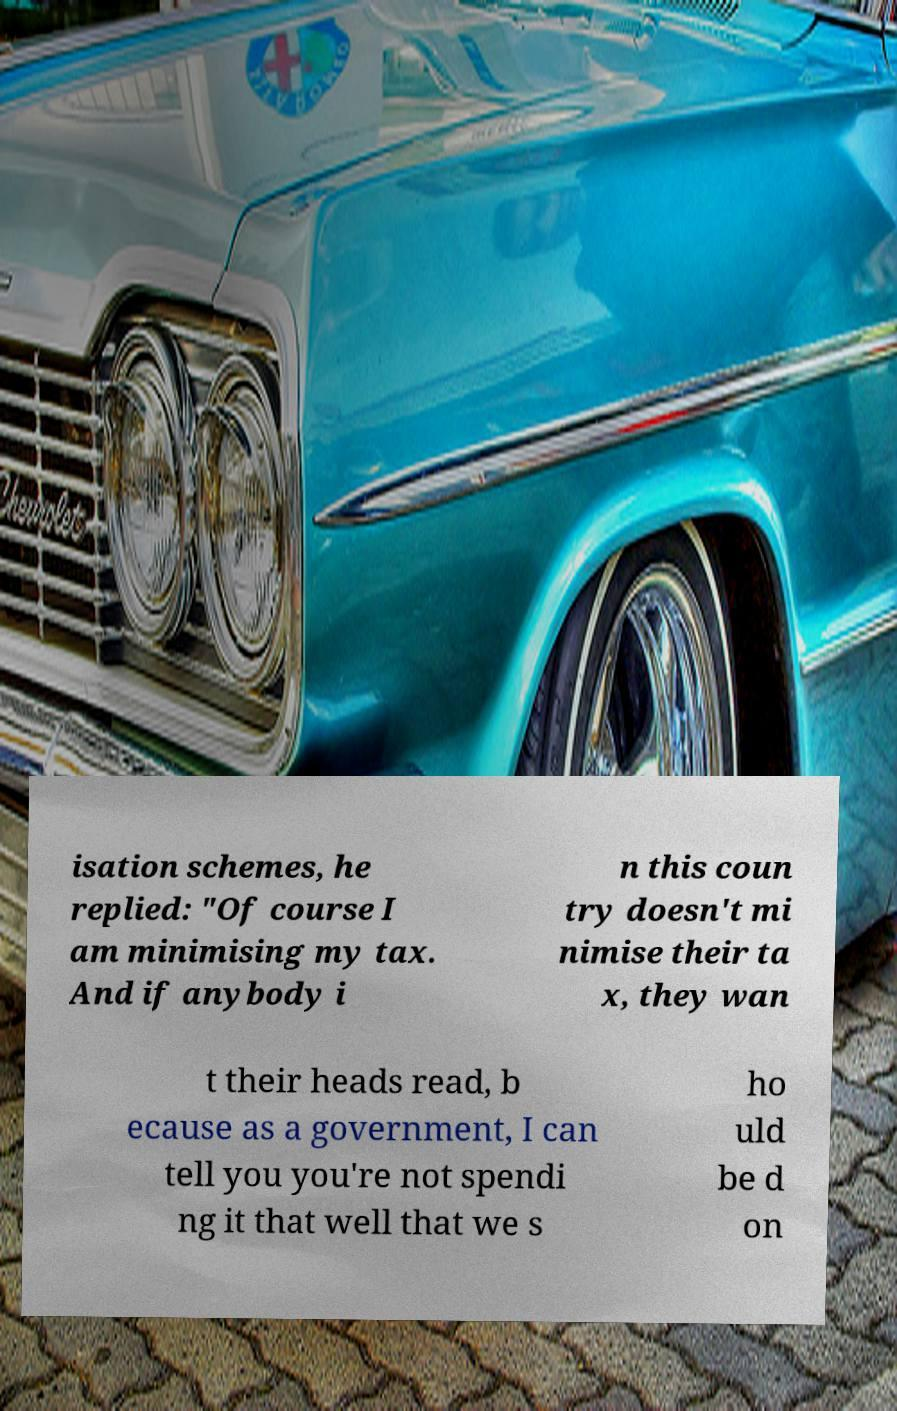Could you extract and type out the text from this image? isation schemes, he replied: "Of course I am minimising my tax. And if anybody i n this coun try doesn't mi nimise their ta x, they wan t their heads read, b ecause as a government, I can tell you you're not spendi ng it that well that we s ho uld be d on 